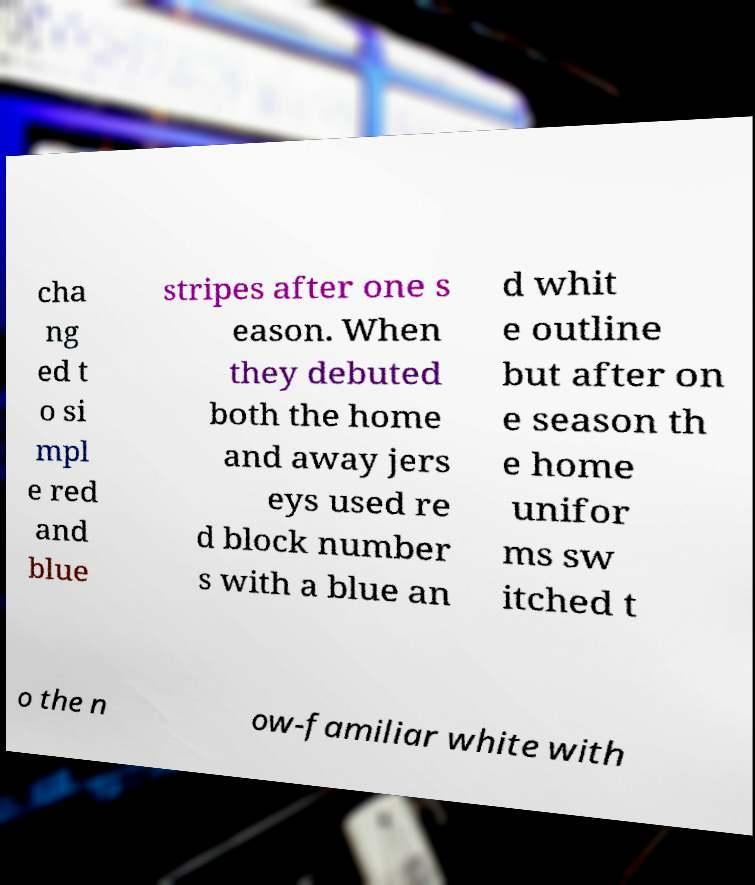Please identify and transcribe the text found in this image. cha ng ed t o si mpl e red and blue stripes after one s eason. When they debuted both the home and away jers eys used re d block number s with a blue an d whit e outline but after on e season th e home unifor ms sw itched t o the n ow-familiar white with 